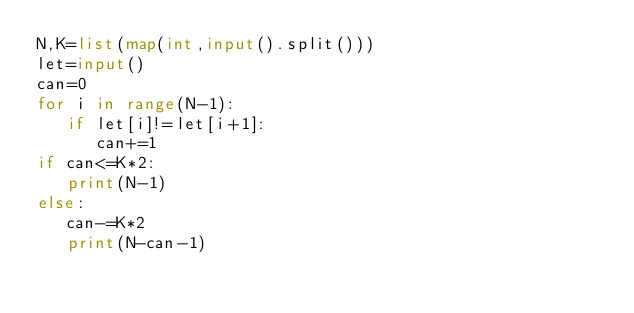<code> <loc_0><loc_0><loc_500><loc_500><_Python_>N,K=list(map(int,input().split()))
let=input()
can=0
for i in range(N-1):
   if let[i]!=let[i+1]:
      can+=1
if can<=K*2:
   print(N-1)
else:
   can-=K*2
   print(N-can-1)</code> 